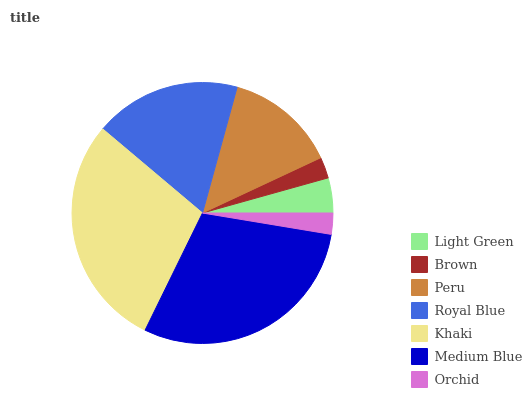Is Orchid the minimum?
Answer yes or no. Yes. Is Medium Blue the maximum?
Answer yes or no. Yes. Is Brown the minimum?
Answer yes or no. No. Is Brown the maximum?
Answer yes or no. No. Is Light Green greater than Brown?
Answer yes or no. Yes. Is Brown less than Light Green?
Answer yes or no. Yes. Is Brown greater than Light Green?
Answer yes or no. No. Is Light Green less than Brown?
Answer yes or no. No. Is Peru the high median?
Answer yes or no. Yes. Is Peru the low median?
Answer yes or no. Yes. Is Khaki the high median?
Answer yes or no. No. Is Brown the low median?
Answer yes or no. No. 